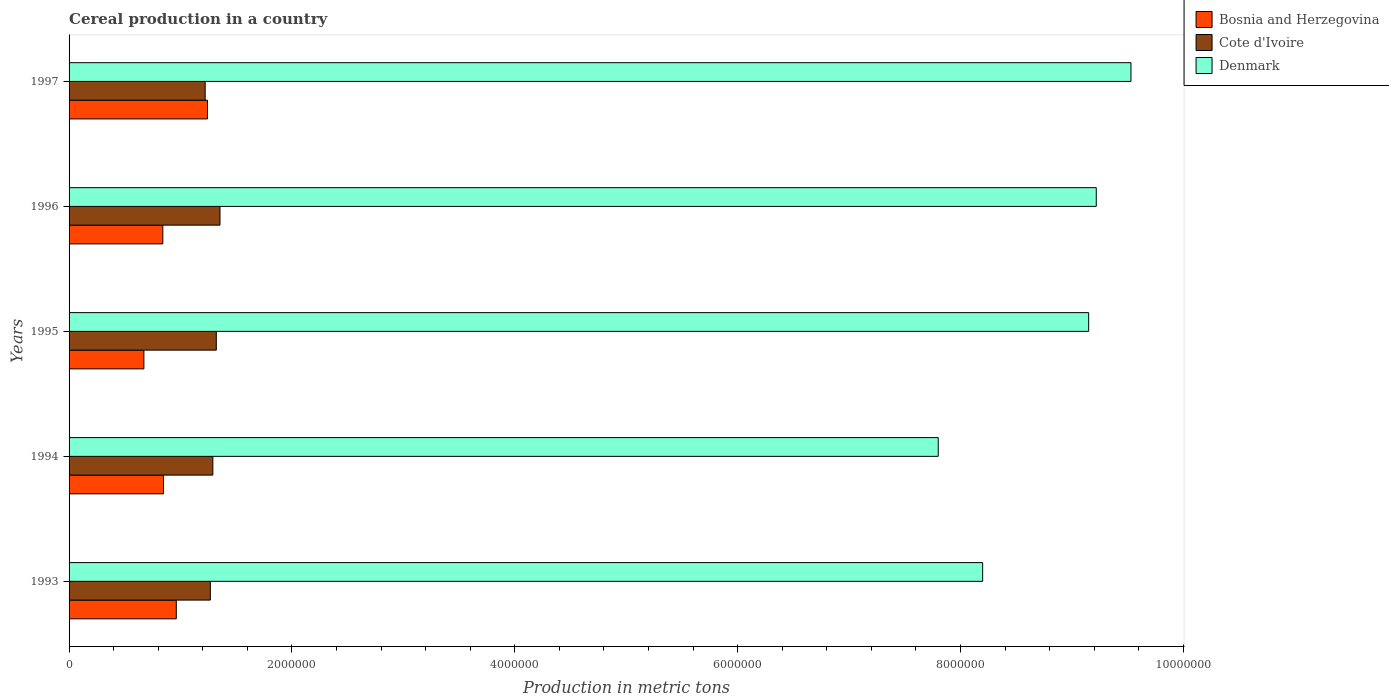How many groups of bars are there?
Give a very brief answer. 5. What is the label of the 2nd group of bars from the top?
Keep it short and to the point. 1996. In how many cases, is the number of bars for a given year not equal to the number of legend labels?
Your response must be concise. 0. What is the total cereal production in Denmark in 1995?
Ensure brevity in your answer.  9.15e+06. Across all years, what is the maximum total cereal production in Denmark?
Offer a terse response. 9.53e+06. Across all years, what is the minimum total cereal production in Bosnia and Herzegovina?
Your answer should be very brief. 6.71e+05. In which year was the total cereal production in Denmark maximum?
Ensure brevity in your answer.  1997. In which year was the total cereal production in Bosnia and Herzegovina minimum?
Your response must be concise. 1995. What is the total total cereal production in Cote d'Ivoire in the graph?
Your answer should be very brief. 6.45e+06. What is the difference between the total cereal production in Denmark in 1993 and that in 1995?
Your answer should be compact. -9.51e+05. What is the difference between the total cereal production in Denmark in 1993 and the total cereal production in Cote d'Ivoire in 1996?
Keep it short and to the point. 6.84e+06. What is the average total cereal production in Denmark per year?
Make the answer very short. 8.78e+06. In the year 1997, what is the difference between the total cereal production in Denmark and total cereal production in Cote d'Ivoire?
Your answer should be compact. 8.31e+06. In how many years, is the total cereal production in Cote d'Ivoire greater than 2400000 metric tons?
Provide a succinct answer. 0. What is the ratio of the total cereal production in Bosnia and Herzegovina in 1995 to that in 1997?
Make the answer very short. 0.54. What is the difference between the highest and the second highest total cereal production in Bosnia and Herzegovina?
Your answer should be very brief. 2.80e+05. What is the difference between the highest and the lowest total cereal production in Bosnia and Herzegovina?
Offer a very short reply. 5.71e+05. Is the sum of the total cereal production in Denmark in 1994 and 1996 greater than the maximum total cereal production in Cote d'Ivoire across all years?
Provide a short and direct response. Yes. What does the 1st bar from the bottom in 1993 represents?
Make the answer very short. Bosnia and Herzegovina. How many bars are there?
Offer a terse response. 15. Are all the bars in the graph horizontal?
Your response must be concise. Yes. How many years are there in the graph?
Your response must be concise. 5. Are the values on the major ticks of X-axis written in scientific E-notation?
Offer a very short reply. No. Where does the legend appear in the graph?
Make the answer very short. Top right. What is the title of the graph?
Your answer should be very brief. Cereal production in a country. Does "Lesotho" appear as one of the legend labels in the graph?
Keep it short and to the point. No. What is the label or title of the X-axis?
Offer a terse response. Production in metric tons. What is the label or title of the Y-axis?
Provide a short and direct response. Years. What is the Production in metric tons of Bosnia and Herzegovina in 1993?
Give a very brief answer. 9.62e+05. What is the Production in metric tons of Cote d'Ivoire in 1993?
Offer a very short reply. 1.27e+06. What is the Production in metric tons in Denmark in 1993?
Offer a terse response. 8.20e+06. What is the Production in metric tons of Bosnia and Herzegovina in 1994?
Your response must be concise. 8.47e+05. What is the Production in metric tons in Cote d'Ivoire in 1994?
Make the answer very short. 1.29e+06. What is the Production in metric tons in Denmark in 1994?
Your answer should be very brief. 7.80e+06. What is the Production in metric tons of Bosnia and Herzegovina in 1995?
Keep it short and to the point. 6.71e+05. What is the Production in metric tons in Cote d'Ivoire in 1995?
Your answer should be compact. 1.32e+06. What is the Production in metric tons in Denmark in 1995?
Make the answer very short. 9.15e+06. What is the Production in metric tons of Bosnia and Herzegovina in 1996?
Your answer should be compact. 8.41e+05. What is the Production in metric tons of Cote d'Ivoire in 1996?
Make the answer very short. 1.35e+06. What is the Production in metric tons in Denmark in 1996?
Keep it short and to the point. 9.22e+06. What is the Production in metric tons in Bosnia and Herzegovina in 1997?
Provide a succinct answer. 1.24e+06. What is the Production in metric tons of Cote d'Ivoire in 1997?
Your response must be concise. 1.22e+06. What is the Production in metric tons of Denmark in 1997?
Offer a terse response. 9.53e+06. Across all years, what is the maximum Production in metric tons in Bosnia and Herzegovina?
Ensure brevity in your answer.  1.24e+06. Across all years, what is the maximum Production in metric tons in Cote d'Ivoire?
Your answer should be compact. 1.35e+06. Across all years, what is the maximum Production in metric tons in Denmark?
Keep it short and to the point. 9.53e+06. Across all years, what is the minimum Production in metric tons of Bosnia and Herzegovina?
Provide a succinct answer. 6.71e+05. Across all years, what is the minimum Production in metric tons of Cote d'Ivoire?
Your response must be concise. 1.22e+06. Across all years, what is the minimum Production in metric tons in Denmark?
Your response must be concise. 7.80e+06. What is the total Production in metric tons in Bosnia and Herzegovina in the graph?
Your response must be concise. 4.56e+06. What is the total Production in metric tons in Cote d'Ivoire in the graph?
Your answer should be very brief. 6.45e+06. What is the total Production in metric tons of Denmark in the graph?
Offer a terse response. 4.39e+07. What is the difference between the Production in metric tons of Bosnia and Herzegovina in 1993 and that in 1994?
Give a very brief answer. 1.15e+05. What is the difference between the Production in metric tons in Cote d'Ivoire in 1993 and that in 1994?
Offer a very short reply. -2.26e+04. What is the difference between the Production in metric tons in Denmark in 1993 and that in 1994?
Your response must be concise. 3.98e+05. What is the difference between the Production in metric tons in Bosnia and Herzegovina in 1993 and that in 1995?
Provide a succinct answer. 2.91e+05. What is the difference between the Production in metric tons of Cote d'Ivoire in 1993 and that in 1995?
Make the answer very short. -5.37e+04. What is the difference between the Production in metric tons of Denmark in 1993 and that in 1995?
Provide a succinct answer. -9.51e+05. What is the difference between the Production in metric tons in Bosnia and Herzegovina in 1993 and that in 1996?
Provide a succinct answer. 1.21e+05. What is the difference between the Production in metric tons of Cote d'Ivoire in 1993 and that in 1996?
Give a very brief answer. -8.66e+04. What is the difference between the Production in metric tons of Denmark in 1993 and that in 1996?
Ensure brevity in your answer.  -1.02e+06. What is the difference between the Production in metric tons in Bosnia and Herzegovina in 1993 and that in 1997?
Ensure brevity in your answer.  -2.80e+05. What is the difference between the Production in metric tons of Cote d'Ivoire in 1993 and that in 1997?
Your answer should be compact. 4.62e+04. What is the difference between the Production in metric tons in Denmark in 1993 and that in 1997?
Give a very brief answer. -1.33e+06. What is the difference between the Production in metric tons in Bosnia and Herzegovina in 1994 and that in 1995?
Your answer should be compact. 1.76e+05. What is the difference between the Production in metric tons of Cote d'Ivoire in 1994 and that in 1995?
Your answer should be very brief. -3.12e+04. What is the difference between the Production in metric tons of Denmark in 1994 and that in 1995?
Ensure brevity in your answer.  -1.35e+06. What is the difference between the Production in metric tons in Bosnia and Herzegovina in 1994 and that in 1996?
Offer a terse response. 6000. What is the difference between the Production in metric tons of Cote d'Ivoire in 1994 and that in 1996?
Offer a very short reply. -6.40e+04. What is the difference between the Production in metric tons of Denmark in 1994 and that in 1996?
Provide a succinct answer. -1.42e+06. What is the difference between the Production in metric tons of Bosnia and Herzegovina in 1994 and that in 1997?
Make the answer very short. -3.95e+05. What is the difference between the Production in metric tons of Cote d'Ivoire in 1994 and that in 1997?
Ensure brevity in your answer.  6.88e+04. What is the difference between the Production in metric tons in Denmark in 1994 and that in 1997?
Ensure brevity in your answer.  -1.73e+06. What is the difference between the Production in metric tons in Bosnia and Herzegovina in 1995 and that in 1996?
Ensure brevity in your answer.  -1.70e+05. What is the difference between the Production in metric tons in Cote d'Ivoire in 1995 and that in 1996?
Your response must be concise. -3.28e+04. What is the difference between the Production in metric tons of Denmark in 1995 and that in 1996?
Make the answer very short. -6.81e+04. What is the difference between the Production in metric tons in Bosnia and Herzegovina in 1995 and that in 1997?
Provide a succinct answer. -5.71e+05. What is the difference between the Production in metric tons in Cote d'Ivoire in 1995 and that in 1997?
Ensure brevity in your answer.  1.00e+05. What is the difference between the Production in metric tons of Denmark in 1995 and that in 1997?
Make the answer very short. -3.79e+05. What is the difference between the Production in metric tons in Bosnia and Herzegovina in 1996 and that in 1997?
Your response must be concise. -4.01e+05. What is the difference between the Production in metric tons of Cote d'Ivoire in 1996 and that in 1997?
Provide a short and direct response. 1.33e+05. What is the difference between the Production in metric tons of Denmark in 1996 and that in 1997?
Your answer should be compact. -3.11e+05. What is the difference between the Production in metric tons in Bosnia and Herzegovina in 1993 and the Production in metric tons in Cote d'Ivoire in 1994?
Ensure brevity in your answer.  -3.28e+05. What is the difference between the Production in metric tons of Bosnia and Herzegovina in 1993 and the Production in metric tons of Denmark in 1994?
Your answer should be compact. -6.84e+06. What is the difference between the Production in metric tons of Cote d'Ivoire in 1993 and the Production in metric tons of Denmark in 1994?
Your response must be concise. -6.53e+06. What is the difference between the Production in metric tons in Bosnia and Herzegovina in 1993 and the Production in metric tons in Cote d'Ivoire in 1995?
Provide a short and direct response. -3.59e+05. What is the difference between the Production in metric tons of Bosnia and Herzegovina in 1993 and the Production in metric tons of Denmark in 1995?
Ensure brevity in your answer.  -8.19e+06. What is the difference between the Production in metric tons of Cote d'Ivoire in 1993 and the Production in metric tons of Denmark in 1995?
Ensure brevity in your answer.  -7.88e+06. What is the difference between the Production in metric tons of Bosnia and Herzegovina in 1993 and the Production in metric tons of Cote d'Ivoire in 1996?
Your answer should be compact. -3.92e+05. What is the difference between the Production in metric tons of Bosnia and Herzegovina in 1993 and the Production in metric tons of Denmark in 1996?
Make the answer very short. -8.26e+06. What is the difference between the Production in metric tons of Cote d'Ivoire in 1993 and the Production in metric tons of Denmark in 1996?
Give a very brief answer. -7.95e+06. What is the difference between the Production in metric tons of Bosnia and Herzegovina in 1993 and the Production in metric tons of Cote d'Ivoire in 1997?
Make the answer very short. -2.59e+05. What is the difference between the Production in metric tons in Bosnia and Herzegovina in 1993 and the Production in metric tons in Denmark in 1997?
Offer a very short reply. -8.57e+06. What is the difference between the Production in metric tons in Cote d'Ivoire in 1993 and the Production in metric tons in Denmark in 1997?
Keep it short and to the point. -8.26e+06. What is the difference between the Production in metric tons of Bosnia and Herzegovina in 1994 and the Production in metric tons of Cote d'Ivoire in 1995?
Your answer should be compact. -4.74e+05. What is the difference between the Production in metric tons in Bosnia and Herzegovina in 1994 and the Production in metric tons in Denmark in 1995?
Offer a very short reply. -8.30e+06. What is the difference between the Production in metric tons of Cote d'Ivoire in 1994 and the Production in metric tons of Denmark in 1995?
Your answer should be compact. -7.86e+06. What is the difference between the Production in metric tons in Bosnia and Herzegovina in 1994 and the Production in metric tons in Cote d'Ivoire in 1996?
Provide a succinct answer. -5.07e+05. What is the difference between the Production in metric tons in Bosnia and Herzegovina in 1994 and the Production in metric tons in Denmark in 1996?
Provide a short and direct response. -8.37e+06. What is the difference between the Production in metric tons of Cote d'Ivoire in 1994 and the Production in metric tons of Denmark in 1996?
Make the answer very short. -7.93e+06. What is the difference between the Production in metric tons of Bosnia and Herzegovina in 1994 and the Production in metric tons of Cote d'Ivoire in 1997?
Keep it short and to the point. -3.74e+05. What is the difference between the Production in metric tons in Bosnia and Herzegovina in 1994 and the Production in metric tons in Denmark in 1997?
Provide a short and direct response. -8.68e+06. What is the difference between the Production in metric tons in Cote d'Ivoire in 1994 and the Production in metric tons in Denmark in 1997?
Make the answer very short. -8.24e+06. What is the difference between the Production in metric tons in Bosnia and Herzegovina in 1995 and the Production in metric tons in Cote d'Ivoire in 1996?
Make the answer very short. -6.83e+05. What is the difference between the Production in metric tons of Bosnia and Herzegovina in 1995 and the Production in metric tons of Denmark in 1996?
Keep it short and to the point. -8.55e+06. What is the difference between the Production in metric tons of Cote d'Ivoire in 1995 and the Production in metric tons of Denmark in 1996?
Offer a terse response. -7.90e+06. What is the difference between the Production in metric tons of Bosnia and Herzegovina in 1995 and the Production in metric tons of Cote d'Ivoire in 1997?
Give a very brief answer. -5.50e+05. What is the difference between the Production in metric tons of Bosnia and Herzegovina in 1995 and the Production in metric tons of Denmark in 1997?
Your response must be concise. -8.86e+06. What is the difference between the Production in metric tons in Cote d'Ivoire in 1995 and the Production in metric tons in Denmark in 1997?
Your answer should be compact. -8.21e+06. What is the difference between the Production in metric tons of Bosnia and Herzegovina in 1996 and the Production in metric tons of Cote d'Ivoire in 1997?
Your response must be concise. -3.80e+05. What is the difference between the Production in metric tons in Bosnia and Herzegovina in 1996 and the Production in metric tons in Denmark in 1997?
Give a very brief answer. -8.69e+06. What is the difference between the Production in metric tons in Cote d'Ivoire in 1996 and the Production in metric tons in Denmark in 1997?
Your response must be concise. -8.18e+06. What is the average Production in metric tons of Bosnia and Herzegovina per year?
Ensure brevity in your answer.  9.13e+05. What is the average Production in metric tons of Cote d'Ivoire per year?
Your answer should be very brief. 1.29e+06. What is the average Production in metric tons in Denmark per year?
Your answer should be very brief. 8.78e+06. In the year 1993, what is the difference between the Production in metric tons in Bosnia and Herzegovina and Production in metric tons in Cote d'Ivoire?
Provide a short and direct response. -3.05e+05. In the year 1993, what is the difference between the Production in metric tons in Bosnia and Herzegovina and Production in metric tons in Denmark?
Your answer should be very brief. -7.24e+06. In the year 1993, what is the difference between the Production in metric tons of Cote d'Ivoire and Production in metric tons of Denmark?
Your answer should be compact. -6.93e+06. In the year 1994, what is the difference between the Production in metric tons of Bosnia and Herzegovina and Production in metric tons of Cote d'Ivoire?
Your answer should be compact. -4.43e+05. In the year 1994, what is the difference between the Production in metric tons in Bosnia and Herzegovina and Production in metric tons in Denmark?
Offer a very short reply. -6.95e+06. In the year 1994, what is the difference between the Production in metric tons of Cote d'Ivoire and Production in metric tons of Denmark?
Give a very brief answer. -6.51e+06. In the year 1995, what is the difference between the Production in metric tons in Bosnia and Herzegovina and Production in metric tons in Cote d'Ivoire?
Your answer should be compact. -6.50e+05. In the year 1995, what is the difference between the Production in metric tons in Bosnia and Herzegovina and Production in metric tons in Denmark?
Keep it short and to the point. -8.48e+06. In the year 1995, what is the difference between the Production in metric tons in Cote d'Ivoire and Production in metric tons in Denmark?
Keep it short and to the point. -7.83e+06. In the year 1996, what is the difference between the Production in metric tons of Bosnia and Herzegovina and Production in metric tons of Cote d'Ivoire?
Your answer should be very brief. -5.13e+05. In the year 1996, what is the difference between the Production in metric tons in Bosnia and Herzegovina and Production in metric tons in Denmark?
Give a very brief answer. -8.38e+06. In the year 1996, what is the difference between the Production in metric tons in Cote d'Ivoire and Production in metric tons in Denmark?
Your response must be concise. -7.86e+06. In the year 1997, what is the difference between the Production in metric tons in Bosnia and Herzegovina and Production in metric tons in Cote d'Ivoire?
Offer a terse response. 2.06e+04. In the year 1997, what is the difference between the Production in metric tons of Bosnia and Herzegovina and Production in metric tons of Denmark?
Make the answer very short. -8.29e+06. In the year 1997, what is the difference between the Production in metric tons in Cote d'Ivoire and Production in metric tons in Denmark?
Ensure brevity in your answer.  -8.31e+06. What is the ratio of the Production in metric tons in Bosnia and Herzegovina in 1993 to that in 1994?
Your answer should be very brief. 1.14. What is the ratio of the Production in metric tons of Cote d'Ivoire in 1993 to that in 1994?
Ensure brevity in your answer.  0.98. What is the ratio of the Production in metric tons of Denmark in 1993 to that in 1994?
Your response must be concise. 1.05. What is the ratio of the Production in metric tons in Bosnia and Herzegovina in 1993 to that in 1995?
Your response must be concise. 1.43. What is the ratio of the Production in metric tons in Cote d'Ivoire in 1993 to that in 1995?
Make the answer very short. 0.96. What is the ratio of the Production in metric tons of Denmark in 1993 to that in 1995?
Give a very brief answer. 0.9. What is the ratio of the Production in metric tons of Bosnia and Herzegovina in 1993 to that in 1996?
Your answer should be compact. 1.14. What is the ratio of the Production in metric tons of Cote d'Ivoire in 1993 to that in 1996?
Offer a very short reply. 0.94. What is the ratio of the Production in metric tons in Denmark in 1993 to that in 1996?
Make the answer very short. 0.89. What is the ratio of the Production in metric tons of Bosnia and Herzegovina in 1993 to that in 1997?
Your response must be concise. 0.77. What is the ratio of the Production in metric tons in Cote d'Ivoire in 1993 to that in 1997?
Provide a succinct answer. 1.04. What is the ratio of the Production in metric tons in Denmark in 1993 to that in 1997?
Your answer should be very brief. 0.86. What is the ratio of the Production in metric tons of Bosnia and Herzegovina in 1994 to that in 1995?
Provide a short and direct response. 1.26. What is the ratio of the Production in metric tons of Cote d'Ivoire in 1994 to that in 1995?
Your response must be concise. 0.98. What is the ratio of the Production in metric tons in Denmark in 1994 to that in 1995?
Ensure brevity in your answer.  0.85. What is the ratio of the Production in metric tons of Bosnia and Herzegovina in 1994 to that in 1996?
Your answer should be compact. 1.01. What is the ratio of the Production in metric tons in Cote d'Ivoire in 1994 to that in 1996?
Give a very brief answer. 0.95. What is the ratio of the Production in metric tons of Denmark in 1994 to that in 1996?
Your response must be concise. 0.85. What is the ratio of the Production in metric tons in Bosnia and Herzegovina in 1994 to that in 1997?
Your response must be concise. 0.68. What is the ratio of the Production in metric tons of Cote d'Ivoire in 1994 to that in 1997?
Offer a very short reply. 1.06. What is the ratio of the Production in metric tons in Denmark in 1994 to that in 1997?
Your answer should be compact. 0.82. What is the ratio of the Production in metric tons in Bosnia and Herzegovina in 1995 to that in 1996?
Your answer should be very brief. 0.8. What is the ratio of the Production in metric tons in Cote d'Ivoire in 1995 to that in 1996?
Offer a terse response. 0.98. What is the ratio of the Production in metric tons of Denmark in 1995 to that in 1996?
Keep it short and to the point. 0.99. What is the ratio of the Production in metric tons in Bosnia and Herzegovina in 1995 to that in 1997?
Your response must be concise. 0.54. What is the ratio of the Production in metric tons in Cote d'Ivoire in 1995 to that in 1997?
Offer a very short reply. 1.08. What is the ratio of the Production in metric tons in Denmark in 1995 to that in 1997?
Provide a succinct answer. 0.96. What is the ratio of the Production in metric tons of Bosnia and Herzegovina in 1996 to that in 1997?
Ensure brevity in your answer.  0.68. What is the ratio of the Production in metric tons in Cote d'Ivoire in 1996 to that in 1997?
Provide a short and direct response. 1.11. What is the ratio of the Production in metric tons of Denmark in 1996 to that in 1997?
Your answer should be compact. 0.97. What is the difference between the highest and the second highest Production in metric tons of Bosnia and Herzegovina?
Make the answer very short. 2.80e+05. What is the difference between the highest and the second highest Production in metric tons of Cote d'Ivoire?
Provide a short and direct response. 3.28e+04. What is the difference between the highest and the second highest Production in metric tons in Denmark?
Ensure brevity in your answer.  3.11e+05. What is the difference between the highest and the lowest Production in metric tons of Bosnia and Herzegovina?
Your response must be concise. 5.71e+05. What is the difference between the highest and the lowest Production in metric tons of Cote d'Ivoire?
Provide a short and direct response. 1.33e+05. What is the difference between the highest and the lowest Production in metric tons of Denmark?
Your response must be concise. 1.73e+06. 